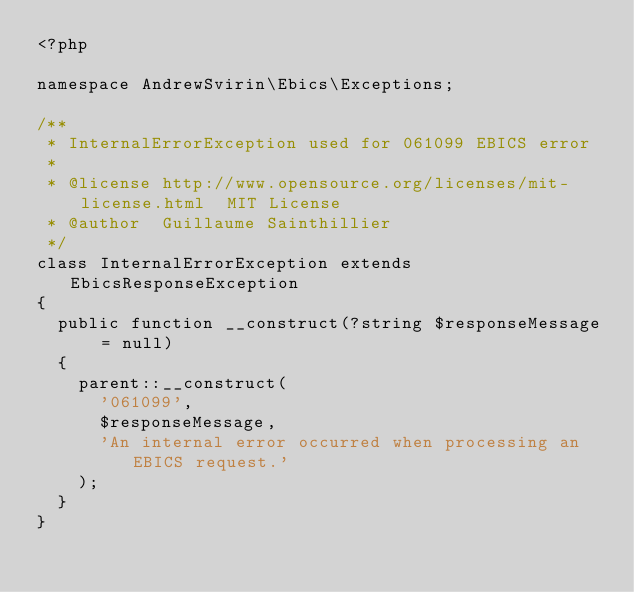Convert code to text. <code><loc_0><loc_0><loc_500><loc_500><_PHP_><?php

namespace AndrewSvirin\Ebics\Exceptions;

/**
 * InternalErrorException used for 061099 EBICS error
 *
 * @license http://www.opensource.org/licenses/mit-license.html  MIT License
 * @author  Guillaume Sainthillier
 */
class InternalErrorException extends EbicsResponseException
{
	public function __construct(?string $responseMessage = null)
	{
		parent::__construct(
			'061099',
			$responseMessage,
			'An internal error occurred when processing an EBICS request.'
		);
	}
}
</code> 